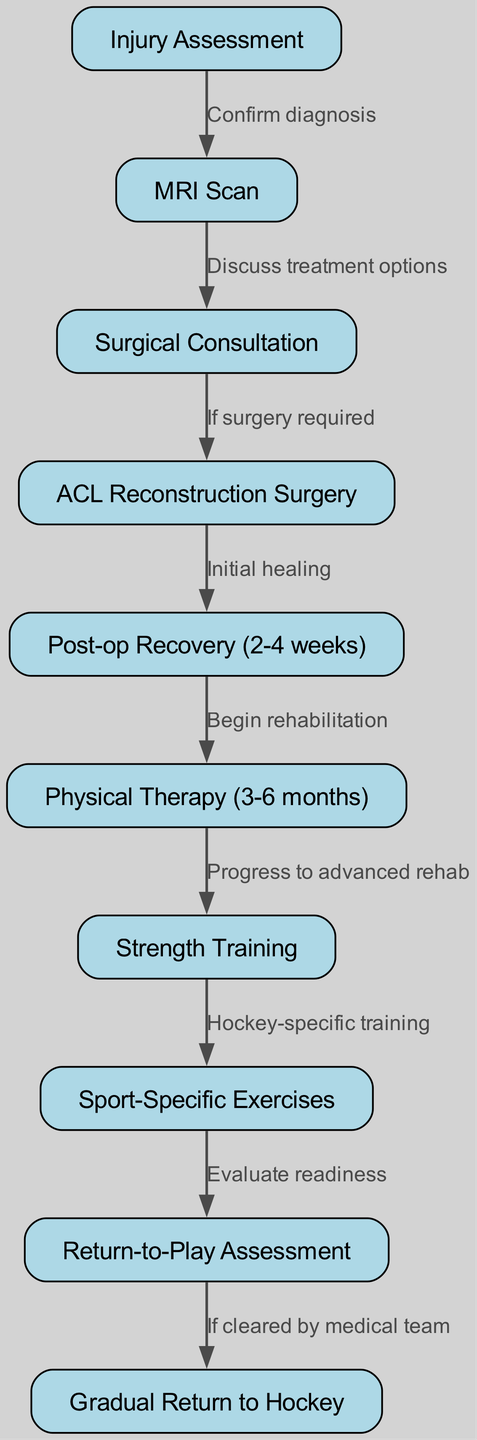What is the first step in the rehabilitation pathway? The first step is "Injury Assessment", as it is the starting node in the diagram.
Answer: Injury Assessment How many nodes are present in the diagram? By counting all the nodes listed in the diagram, there are a total of 10 nodes, each representing a step in the rehabilitation process.
Answer: 10 Which node follows Physical Therapy? After "Physical Therapy", the next step in the diagram is "Strength Training", indicating a progression in the rehabilitation process.
Answer: Strength Training What is the relationship between MRI Scan and Surgical Consultation? The relationship is that a "MRI Scan" is conducted to "Discuss treatment options" with the "Surgical Consultation", as indicated by the directed edge from the MRI node to the surgery consultation node.
Answer: Discuss treatment options If ACL Reconstruction Surgery is performed, what is the subsequent step? Following "ACL Reconstruction Surgery", the next step is "Post-op Recovery (2-4 weeks)", indicating the immediate recovery period after surgery.
Answer: Post-op Recovery (2-4 weeks) What needs to happen for an athlete to proceed to the Gradual Return to Hockey phase? An athlete must be "Cleared by medical team" after completing the "Return-to-Play Assessment" to proceed to the gradual return phase, as shown in the diagram.
Answer: Cleared by medical team What does the edge labeled "Evaluate readiness" connect? The edge labeled "Evaluate readiness" connects "Sport-Specific Exercises" to "Return-to-Play Assessment", indicating the evaluation of the athlete's readiness to return to play after completing specific exercises.
Answer: Return-to-Play Assessment What is the total number of edges in the diagram? By counting the connections that show relationships between the steps, there are a total of 9 edges in the diagram.
Answer: 9 What is the purpose of the Strength Training phase? The purpose of the "Strength Training" phase, following physical therapy, is to progress to advanced rehabilitation by building strength, preparing the athlete for sport-specific exercises.
Answer: Progress to advanced rehab 